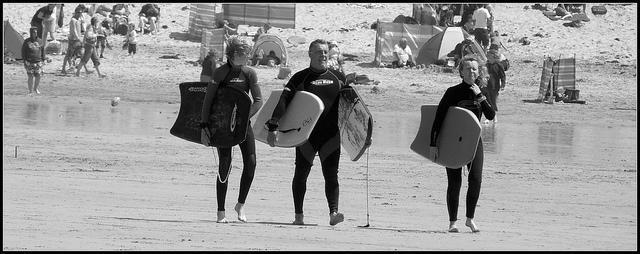How many people are carrying surfboards?
Give a very brief answer. 3. How many surfboards can be seen?
Give a very brief answer. 4. How many people can you see?
Give a very brief answer. 3. How many exhaust pipes does the truck have?
Give a very brief answer. 0. 